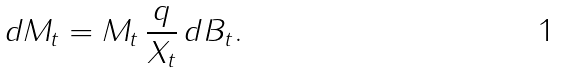<formula> <loc_0><loc_0><loc_500><loc_500>d M _ { t } = M _ { t } \, \frac { q } { X _ { t } } \, d B _ { t } .</formula> 